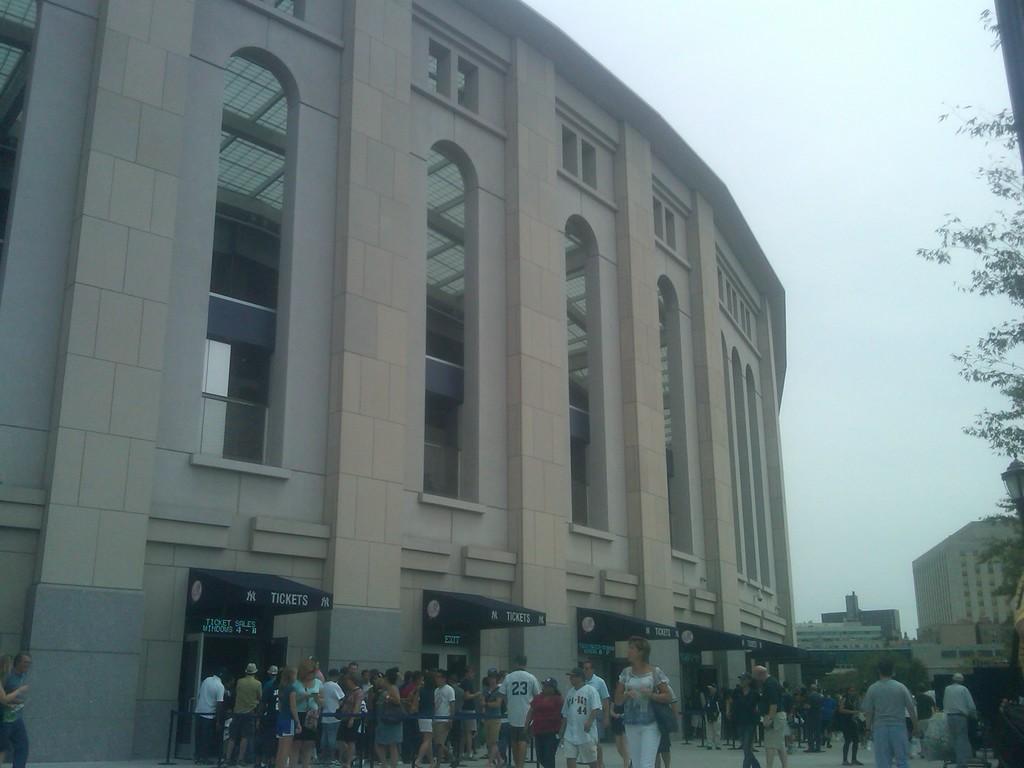Could you give a brief overview of what you see in this image? This is an outside view. At the bottom, I can see many people on the ground. Few are standing, few are walking. In the background there are many buildings. On the right side few leaves are visible. At the top of the image I can see the sky. 